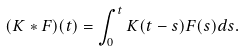<formula> <loc_0><loc_0><loc_500><loc_500>( K * F ) ( t ) = \int _ { 0 } ^ { t } K ( t - s ) F ( s ) d s .</formula> 